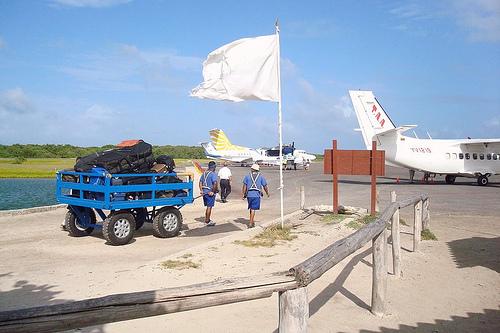Is there a fence somewhere?
Keep it brief. Yes. What type of weather is it?
Write a very short answer. Sunny. Is it cold here?
Short answer required. No. Is this in the United States?
Keep it brief. No. Is this a luggage cart?
Be succinct. Yes. How many men are wearing vests?
Give a very brief answer. 2. Are there mountains in the background?
Give a very brief answer. No. What material is the fence made of?
Keep it brief. Wood. What is in the blue cart?
Concise answer only. Luggage. How many flags are in the photo?
Answer briefly. 1. Is it a sunny day?
Answer briefly. Yes. How many blue hard hats are there?
Short answer required. 0. 